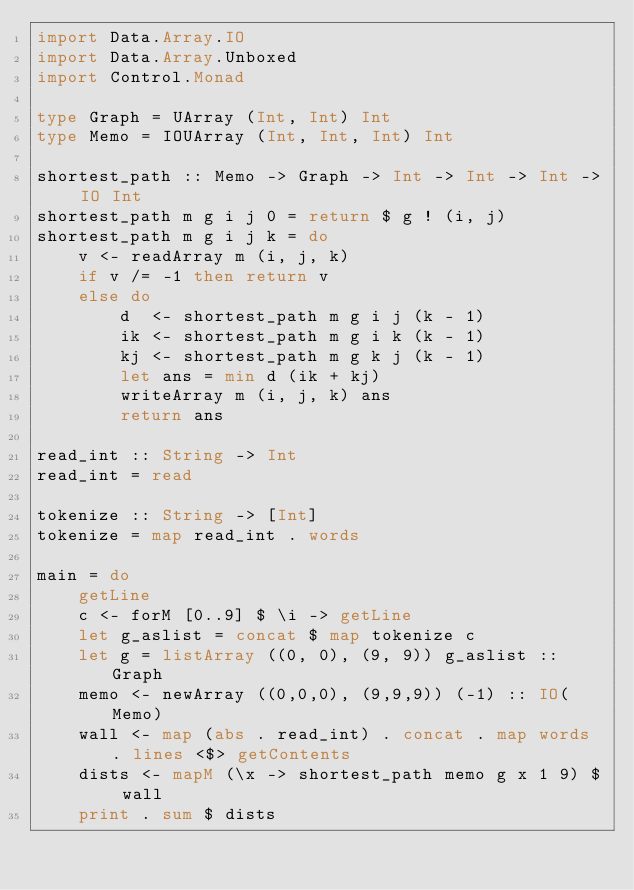<code> <loc_0><loc_0><loc_500><loc_500><_Haskell_>import Data.Array.IO
import Data.Array.Unboxed
import Control.Monad

type Graph = UArray (Int, Int) Int
type Memo = IOUArray (Int, Int, Int) Int

shortest_path :: Memo -> Graph -> Int -> Int -> Int -> IO Int
shortest_path m g i j 0 = return $ g ! (i, j)
shortest_path m g i j k = do
    v <- readArray m (i, j, k)
    if v /= -1 then return v
    else do
        d  <- shortest_path m g i j (k - 1)
        ik <- shortest_path m g i k (k - 1)
        kj <- shortest_path m g k j (k - 1)
        let ans = min d (ik + kj)
        writeArray m (i, j, k) ans
        return ans

read_int :: String -> Int
read_int = read

tokenize :: String -> [Int]
tokenize = map read_int . words

main = do
    getLine
    c <- forM [0..9] $ \i -> getLine
    let g_aslist = concat $ map tokenize c
    let g = listArray ((0, 0), (9, 9)) g_aslist :: Graph
    memo <- newArray ((0,0,0), (9,9,9)) (-1) :: IO(Memo)
    wall <- map (abs . read_int) . concat . map words . lines <$> getContents
    dists <- mapM (\x -> shortest_path memo g x 1 9) $ wall
    print . sum $ dists

</code> 